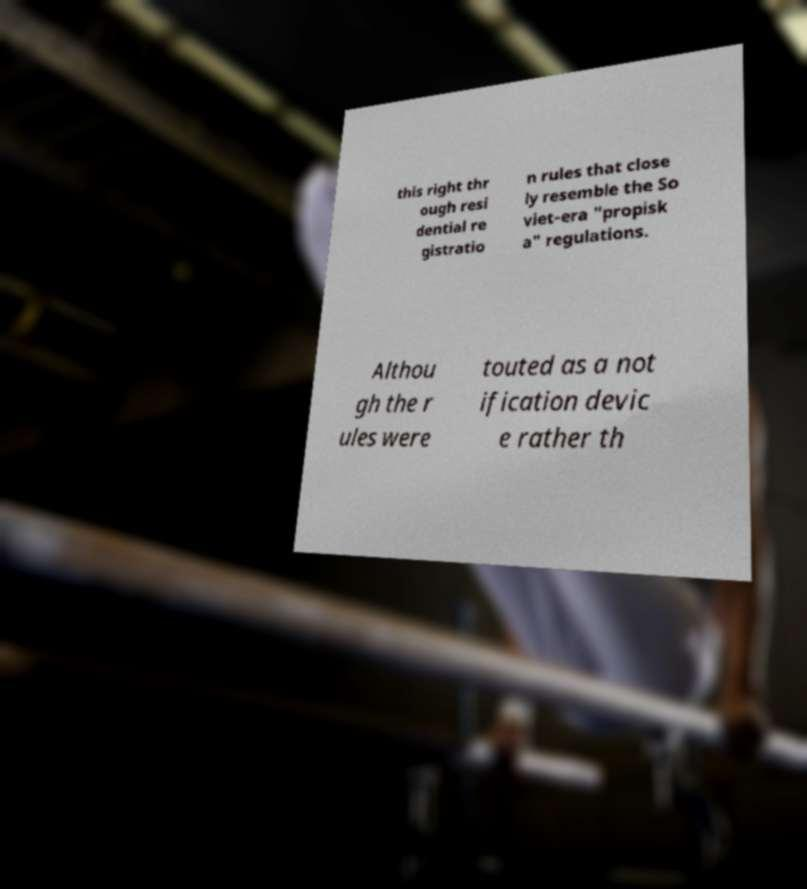Please read and relay the text visible in this image. What does it say? this right thr ough resi dential re gistratio n rules that close ly resemble the So viet-era "propisk a" regulations. Althou gh the r ules were touted as a not ification devic e rather th 